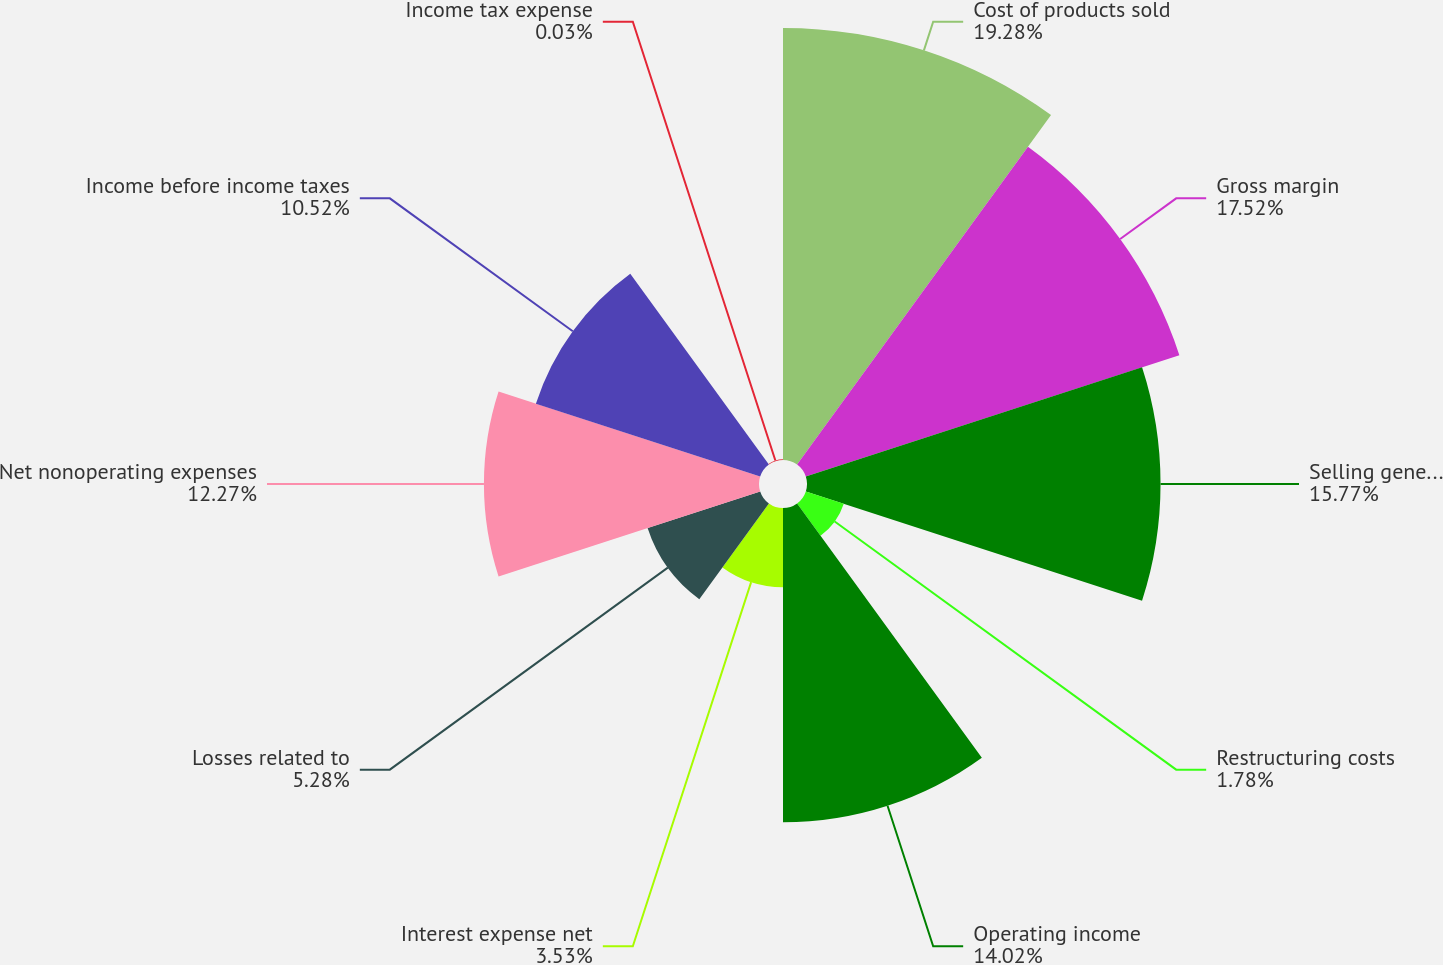<chart> <loc_0><loc_0><loc_500><loc_500><pie_chart><fcel>Cost of products sold<fcel>Gross margin<fcel>Selling general and<fcel>Restructuring costs<fcel>Operating income<fcel>Interest expense net<fcel>Losses related to<fcel>Net nonoperating expenses<fcel>Income before income taxes<fcel>Income tax expense<nl><fcel>19.27%<fcel>17.52%<fcel>15.77%<fcel>1.78%<fcel>14.02%<fcel>3.53%<fcel>5.28%<fcel>12.27%<fcel>10.52%<fcel>0.03%<nl></chart> 